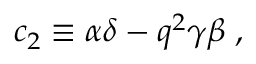Convert formula to latex. <formula><loc_0><loc_0><loc_500><loc_500>c _ { 2 } \equiv \alpha \delta - q ^ { 2 } \gamma \beta \, ,</formula> 